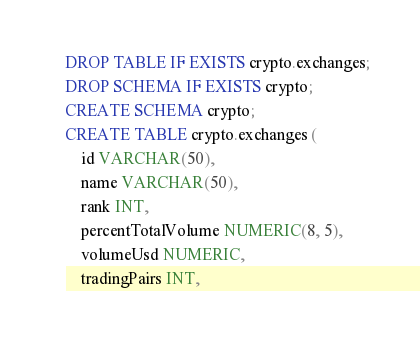Convert code to text. <code><loc_0><loc_0><loc_500><loc_500><_SQL_>DROP TABLE IF EXISTS crypto.exchanges;
DROP SCHEMA IF EXISTS crypto;
CREATE SCHEMA crypto;
CREATE TABLE crypto.exchanges (
    id VARCHAR(50),
    name VARCHAR(50),
    rank INT,
    percentTotalVolume NUMERIC(8, 5),
    volumeUsd NUMERIC,
    tradingPairs INT,</code> 